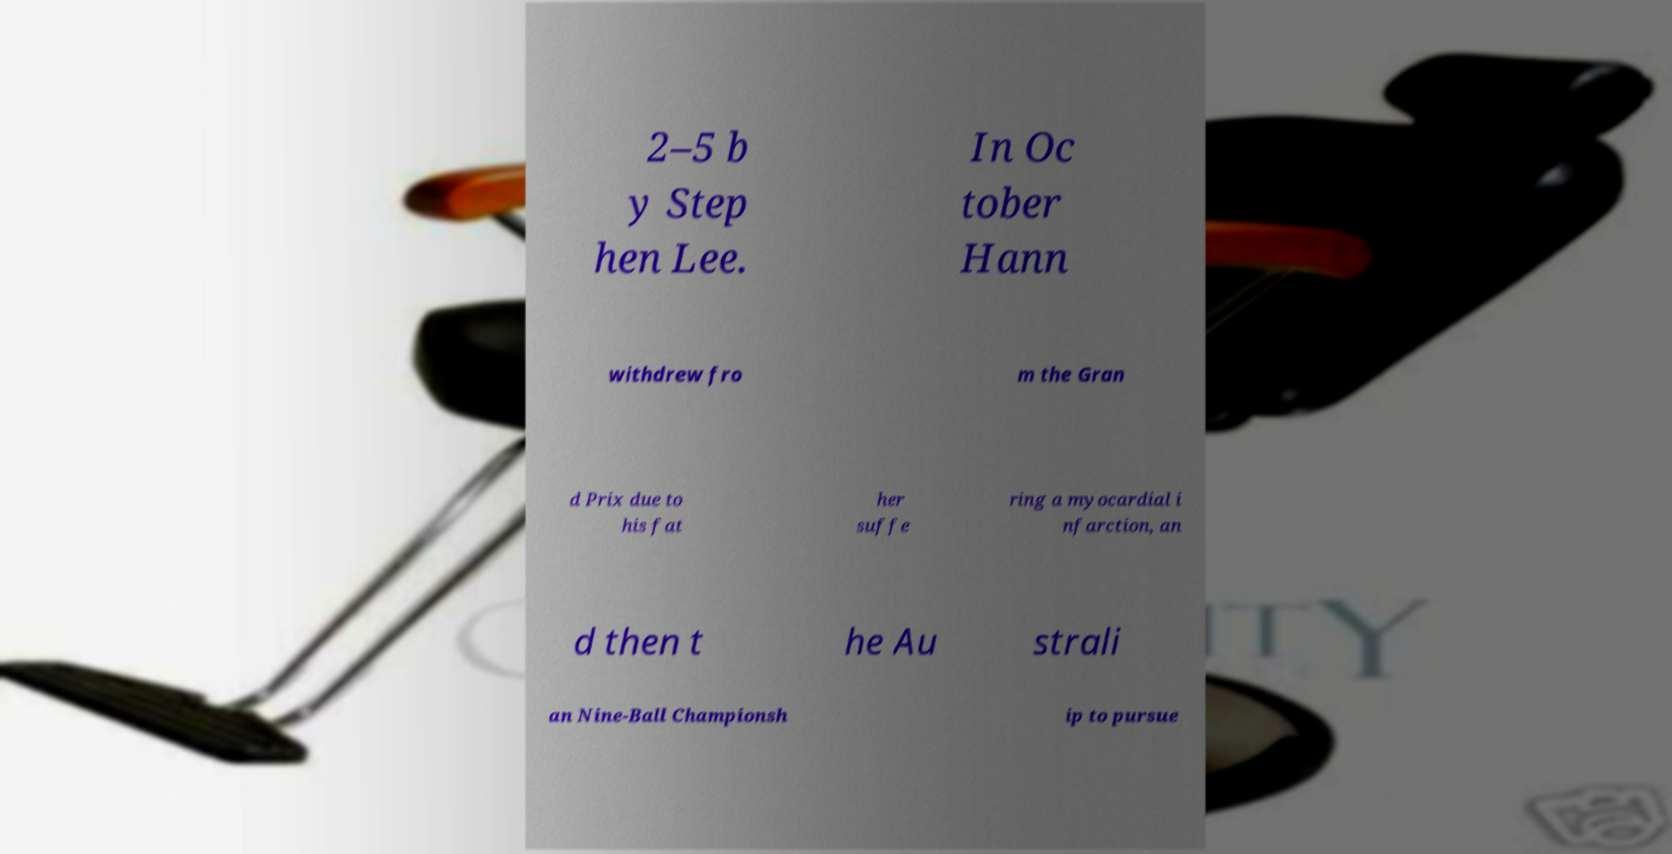Please read and relay the text visible in this image. What does it say? 2–5 b y Step hen Lee. In Oc tober Hann withdrew fro m the Gran d Prix due to his fat her suffe ring a myocardial i nfarction, an d then t he Au strali an Nine-Ball Championsh ip to pursue 